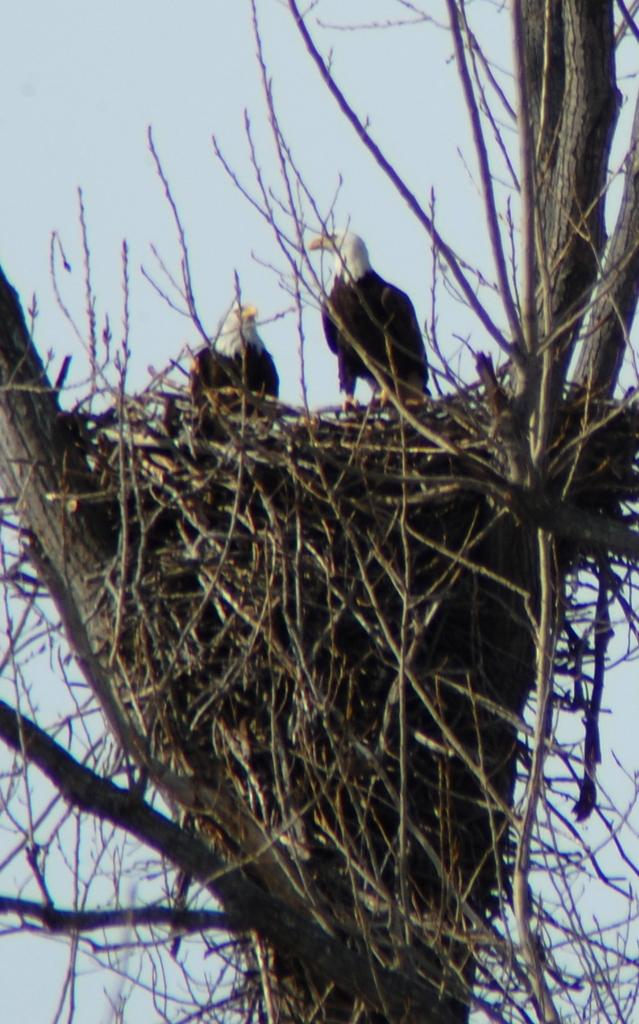How many birds can be seen in the image? There are two birds in the image. Where are the birds located? The birds are on a nest. What can be seen in the background of the image? There are twigs and a dry tree in the background of the image. What is visible at the top of the image? The sky is visible in the background of the image. What type of linen is being used to create a connection between the birds in the image? There is no linen or connection between the birds in the image; they are simply sitting on a nest. 